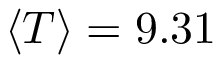Convert formula to latex. <formula><loc_0><loc_0><loc_500><loc_500>\left \langle T \right \rangle = 9 . 3 1</formula> 